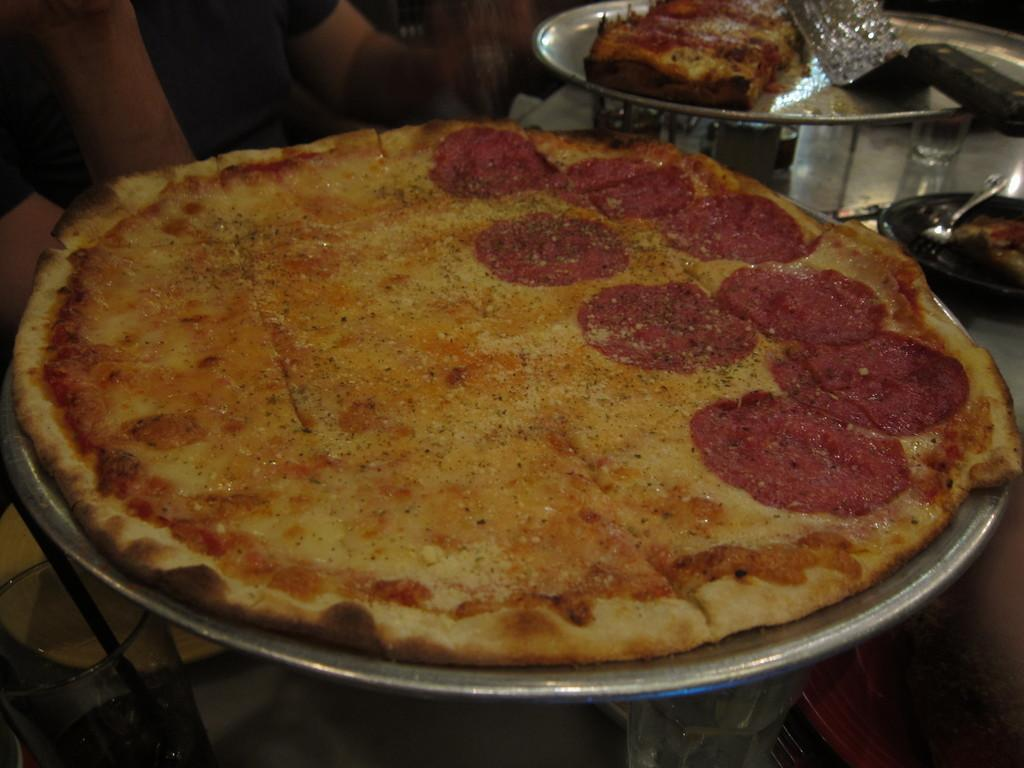What can be found on the platters in the image? There are food items on the platters in the image. What else can be seen in the image besides the platters? There are other objects visible in the image. What might be used for drinking in the image? Glasses are present in the image for drinking. What type of government is depicted in the image? There is no depiction of a government in the image; it features platters with food items, other objects, and glasses. What kind of test can be seen being conducted in the image? There is no test being conducted in the image; it focuses on food items, other objects, and glasses. 